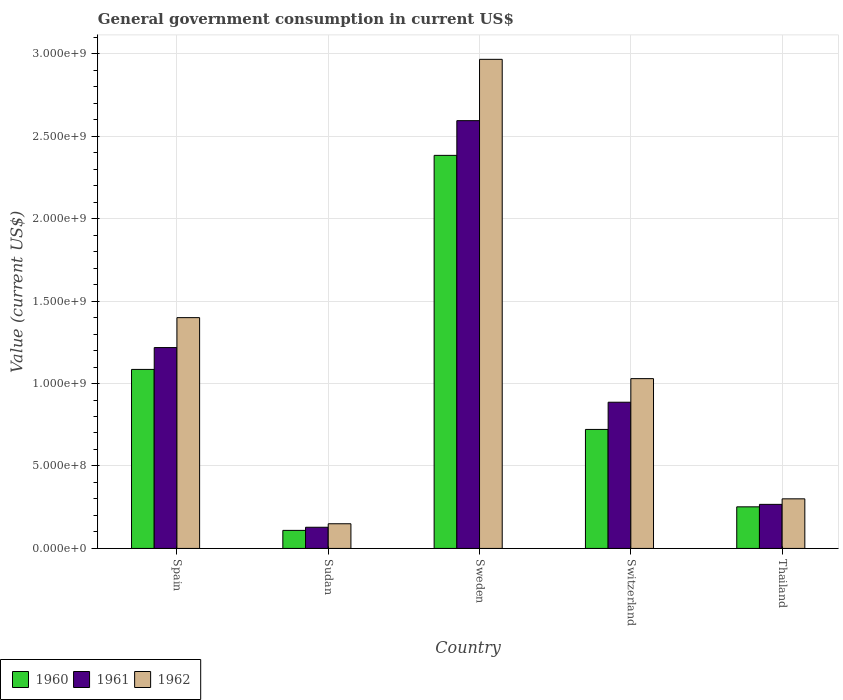How many groups of bars are there?
Your answer should be very brief. 5. Are the number of bars per tick equal to the number of legend labels?
Your response must be concise. Yes. Are the number of bars on each tick of the X-axis equal?
Offer a terse response. Yes. How many bars are there on the 1st tick from the left?
Offer a very short reply. 3. What is the label of the 3rd group of bars from the left?
Your answer should be very brief. Sweden. In how many cases, is the number of bars for a given country not equal to the number of legend labels?
Offer a terse response. 0. What is the government conusmption in 1961 in Switzerland?
Your response must be concise. 8.86e+08. Across all countries, what is the maximum government conusmption in 1960?
Provide a short and direct response. 2.38e+09. Across all countries, what is the minimum government conusmption in 1962?
Keep it short and to the point. 1.50e+08. In which country was the government conusmption in 1962 maximum?
Offer a very short reply. Sweden. In which country was the government conusmption in 1960 minimum?
Give a very brief answer. Sudan. What is the total government conusmption in 1960 in the graph?
Ensure brevity in your answer.  4.55e+09. What is the difference between the government conusmption in 1961 in Spain and that in Sudan?
Your answer should be compact. 1.09e+09. What is the difference between the government conusmption in 1961 in Switzerland and the government conusmption in 1962 in Sudan?
Your response must be concise. 7.37e+08. What is the average government conusmption in 1960 per country?
Give a very brief answer. 9.10e+08. What is the difference between the government conusmption of/in 1960 and government conusmption of/in 1961 in Sweden?
Make the answer very short. -2.10e+08. In how many countries, is the government conusmption in 1961 greater than 1600000000 US$?
Offer a terse response. 1. What is the ratio of the government conusmption in 1960 in Sweden to that in Thailand?
Keep it short and to the point. 9.45. Is the government conusmption in 1962 in Spain less than that in Sweden?
Give a very brief answer. Yes. What is the difference between the highest and the second highest government conusmption in 1960?
Offer a terse response. 1.30e+09. What is the difference between the highest and the lowest government conusmption in 1960?
Your response must be concise. 2.27e+09. In how many countries, is the government conusmption in 1962 greater than the average government conusmption in 1962 taken over all countries?
Offer a terse response. 2. Is it the case that in every country, the sum of the government conusmption in 1960 and government conusmption in 1962 is greater than the government conusmption in 1961?
Give a very brief answer. Yes. How many countries are there in the graph?
Your answer should be very brief. 5. What is the difference between two consecutive major ticks on the Y-axis?
Make the answer very short. 5.00e+08. Does the graph contain any zero values?
Ensure brevity in your answer.  No. How many legend labels are there?
Offer a very short reply. 3. How are the legend labels stacked?
Your answer should be compact. Horizontal. What is the title of the graph?
Your answer should be very brief. General government consumption in current US$. Does "2013" appear as one of the legend labels in the graph?
Ensure brevity in your answer.  No. What is the label or title of the X-axis?
Your answer should be compact. Country. What is the label or title of the Y-axis?
Your answer should be compact. Value (current US$). What is the Value (current US$) in 1960 in Spain?
Ensure brevity in your answer.  1.09e+09. What is the Value (current US$) in 1961 in Spain?
Ensure brevity in your answer.  1.22e+09. What is the Value (current US$) in 1962 in Spain?
Ensure brevity in your answer.  1.40e+09. What is the Value (current US$) in 1960 in Sudan?
Offer a terse response. 1.09e+08. What is the Value (current US$) of 1961 in Sudan?
Your answer should be very brief. 1.28e+08. What is the Value (current US$) of 1962 in Sudan?
Provide a short and direct response. 1.50e+08. What is the Value (current US$) in 1960 in Sweden?
Your response must be concise. 2.38e+09. What is the Value (current US$) in 1961 in Sweden?
Provide a short and direct response. 2.59e+09. What is the Value (current US$) of 1962 in Sweden?
Offer a very short reply. 2.97e+09. What is the Value (current US$) of 1960 in Switzerland?
Provide a succinct answer. 7.22e+08. What is the Value (current US$) in 1961 in Switzerland?
Your response must be concise. 8.86e+08. What is the Value (current US$) of 1962 in Switzerland?
Provide a short and direct response. 1.03e+09. What is the Value (current US$) in 1960 in Thailand?
Give a very brief answer. 2.52e+08. What is the Value (current US$) in 1961 in Thailand?
Ensure brevity in your answer.  2.67e+08. What is the Value (current US$) in 1962 in Thailand?
Ensure brevity in your answer.  3.01e+08. Across all countries, what is the maximum Value (current US$) in 1960?
Your answer should be very brief. 2.38e+09. Across all countries, what is the maximum Value (current US$) of 1961?
Ensure brevity in your answer.  2.59e+09. Across all countries, what is the maximum Value (current US$) of 1962?
Provide a succinct answer. 2.97e+09. Across all countries, what is the minimum Value (current US$) in 1960?
Offer a very short reply. 1.09e+08. Across all countries, what is the minimum Value (current US$) of 1961?
Offer a very short reply. 1.28e+08. Across all countries, what is the minimum Value (current US$) of 1962?
Your answer should be very brief. 1.50e+08. What is the total Value (current US$) in 1960 in the graph?
Ensure brevity in your answer.  4.55e+09. What is the total Value (current US$) in 1961 in the graph?
Keep it short and to the point. 5.09e+09. What is the total Value (current US$) of 1962 in the graph?
Make the answer very short. 5.84e+09. What is the difference between the Value (current US$) of 1960 in Spain and that in Sudan?
Keep it short and to the point. 9.76e+08. What is the difference between the Value (current US$) in 1961 in Spain and that in Sudan?
Your answer should be compact. 1.09e+09. What is the difference between the Value (current US$) of 1962 in Spain and that in Sudan?
Your answer should be compact. 1.25e+09. What is the difference between the Value (current US$) in 1960 in Spain and that in Sweden?
Ensure brevity in your answer.  -1.30e+09. What is the difference between the Value (current US$) of 1961 in Spain and that in Sweden?
Your response must be concise. -1.38e+09. What is the difference between the Value (current US$) in 1962 in Spain and that in Sweden?
Provide a short and direct response. -1.57e+09. What is the difference between the Value (current US$) of 1960 in Spain and that in Switzerland?
Provide a short and direct response. 3.64e+08. What is the difference between the Value (current US$) of 1961 in Spain and that in Switzerland?
Ensure brevity in your answer.  3.31e+08. What is the difference between the Value (current US$) of 1962 in Spain and that in Switzerland?
Your answer should be compact. 3.70e+08. What is the difference between the Value (current US$) in 1960 in Spain and that in Thailand?
Your answer should be compact. 8.33e+08. What is the difference between the Value (current US$) in 1961 in Spain and that in Thailand?
Provide a short and direct response. 9.51e+08. What is the difference between the Value (current US$) of 1962 in Spain and that in Thailand?
Provide a short and direct response. 1.10e+09. What is the difference between the Value (current US$) in 1960 in Sudan and that in Sweden?
Make the answer very short. -2.27e+09. What is the difference between the Value (current US$) of 1961 in Sudan and that in Sweden?
Give a very brief answer. -2.47e+09. What is the difference between the Value (current US$) of 1962 in Sudan and that in Sweden?
Provide a short and direct response. -2.82e+09. What is the difference between the Value (current US$) in 1960 in Sudan and that in Switzerland?
Provide a succinct answer. -6.12e+08. What is the difference between the Value (current US$) in 1961 in Sudan and that in Switzerland?
Give a very brief answer. -7.58e+08. What is the difference between the Value (current US$) in 1962 in Sudan and that in Switzerland?
Ensure brevity in your answer.  -8.80e+08. What is the difference between the Value (current US$) of 1960 in Sudan and that in Thailand?
Provide a short and direct response. -1.43e+08. What is the difference between the Value (current US$) in 1961 in Sudan and that in Thailand?
Ensure brevity in your answer.  -1.39e+08. What is the difference between the Value (current US$) of 1962 in Sudan and that in Thailand?
Your response must be concise. -1.51e+08. What is the difference between the Value (current US$) in 1960 in Sweden and that in Switzerland?
Provide a short and direct response. 1.66e+09. What is the difference between the Value (current US$) of 1961 in Sweden and that in Switzerland?
Make the answer very short. 1.71e+09. What is the difference between the Value (current US$) in 1962 in Sweden and that in Switzerland?
Make the answer very short. 1.94e+09. What is the difference between the Value (current US$) of 1960 in Sweden and that in Thailand?
Your answer should be very brief. 2.13e+09. What is the difference between the Value (current US$) in 1961 in Sweden and that in Thailand?
Make the answer very short. 2.33e+09. What is the difference between the Value (current US$) of 1962 in Sweden and that in Thailand?
Ensure brevity in your answer.  2.66e+09. What is the difference between the Value (current US$) of 1960 in Switzerland and that in Thailand?
Give a very brief answer. 4.69e+08. What is the difference between the Value (current US$) of 1961 in Switzerland and that in Thailand?
Give a very brief answer. 6.19e+08. What is the difference between the Value (current US$) in 1962 in Switzerland and that in Thailand?
Provide a succinct answer. 7.29e+08. What is the difference between the Value (current US$) of 1960 in Spain and the Value (current US$) of 1961 in Sudan?
Give a very brief answer. 9.57e+08. What is the difference between the Value (current US$) in 1960 in Spain and the Value (current US$) in 1962 in Sudan?
Offer a very short reply. 9.36e+08. What is the difference between the Value (current US$) of 1961 in Spain and the Value (current US$) of 1962 in Sudan?
Ensure brevity in your answer.  1.07e+09. What is the difference between the Value (current US$) of 1960 in Spain and the Value (current US$) of 1961 in Sweden?
Make the answer very short. -1.51e+09. What is the difference between the Value (current US$) in 1960 in Spain and the Value (current US$) in 1962 in Sweden?
Provide a succinct answer. -1.88e+09. What is the difference between the Value (current US$) of 1961 in Spain and the Value (current US$) of 1962 in Sweden?
Provide a succinct answer. -1.75e+09. What is the difference between the Value (current US$) in 1960 in Spain and the Value (current US$) in 1961 in Switzerland?
Give a very brief answer. 1.99e+08. What is the difference between the Value (current US$) of 1960 in Spain and the Value (current US$) of 1962 in Switzerland?
Your response must be concise. 5.60e+07. What is the difference between the Value (current US$) of 1961 in Spain and the Value (current US$) of 1962 in Switzerland?
Your response must be concise. 1.88e+08. What is the difference between the Value (current US$) of 1960 in Spain and the Value (current US$) of 1961 in Thailand?
Ensure brevity in your answer.  8.18e+08. What is the difference between the Value (current US$) in 1960 in Spain and the Value (current US$) in 1962 in Thailand?
Provide a short and direct response. 7.85e+08. What is the difference between the Value (current US$) of 1961 in Spain and the Value (current US$) of 1962 in Thailand?
Provide a succinct answer. 9.17e+08. What is the difference between the Value (current US$) of 1960 in Sudan and the Value (current US$) of 1961 in Sweden?
Keep it short and to the point. -2.48e+09. What is the difference between the Value (current US$) of 1960 in Sudan and the Value (current US$) of 1962 in Sweden?
Your answer should be very brief. -2.86e+09. What is the difference between the Value (current US$) in 1961 in Sudan and the Value (current US$) in 1962 in Sweden?
Give a very brief answer. -2.84e+09. What is the difference between the Value (current US$) of 1960 in Sudan and the Value (current US$) of 1961 in Switzerland?
Your answer should be very brief. -7.77e+08. What is the difference between the Value (current US$) of 1960 in Sudan and the Value (current US$) of 1962 in Switzerland?
Your response must be concise. -9.20e+08. What is the difference between the Value (current US$) of 1961 in Sudan and the Value (current US$) of 1962 in Switzerland?
Provide a short and direct response. -9.01e+08. What is the difference between the Value (current US$) in 1960 in Sudan and the Value (current US$) in 1961 in Thailand?
Your answer should be very brief. -1.58e+08. What is the difference between the Value (current US$) in 1960 in Sudan and the Value (current US$) in 1962 in Thailand?
Your answer should be very brief. -1.91e+08. What is the difference between the Value (current US$) in 1961 in Sudan and the Value (current US$) in 1962 in Thailand?
Your answer should be very brief. -1.72e+08. What is the difference between the Value (current US$) of 1960 in Sweden and the Value (current US$) of 1961 in Switzerland?
Ensure brevity in your answer.  1.50e+09. What is the difference between the Value (current US$) in 1960 in Sweden and the Value (current US$) in 1962 in Switzerland?
Provide a succinct answer. 1.35e+09. What is the difference between the Value (current US$) in 1961 in Sweden and the Value (current US$) in 1962 in Switzerland?
Offer a terse response. 1.56e+09. What is the difference between the Value (current US$) in 1960 in Sweden and the Value (current US$) in 1961 in Thailand?
Your answer should be compact. 2.12e+09. What is the difference between the Value (current US$) of 1960 in Sweden and the Value (current US$) of 1962 in Thailand?
Keep it short and to the point. 2.08e+09. What is the difference between the Value (current US$) in 1961 in Sweden and the Value (current US$) in 1962 in Thailand?
Provide a short and direct response. 2.29e+09. What is the difference between the Value (current US$) of 1960 in Switzerland and the Value (current US$) of 1961 in Thailand?
Your answer should be very brief. 4.54e+08. What is the difference between the Value (current US$) in 1960 in Switzerland and the Value (current US$) in 1962 in Thailand?
Ensure brevity in your answer.  4.21e+08. What is the difference between the Value (current US$) in 1961 in Switzerland and the Value (current US$) in 1962 in Thailand?
Your response must be concise. 5.86e+08. What is the average Value (current US$) in 1960 per country?
Make the answer very short. 9.10e+08. What is the average Value (current US$) of 1961 per country?
Your answer should be compact. 1.02e+09. What is the average Value (current US$) of 1962 per country?
Provide a succinct answer. 1.17e+09. What is the difference between the Value (current US$) of 1960 and Value (current US$) of 1961 in Spain?
Ensure brevity in your answer.  -1.32e+08. What is the difference between the Value (current US$) in 1960 and Value (current US$) in 1962 in Spain?
Your answer should be very brief. -3.14e+08. What is the difference between the Value (current US$) of 1961 and Value (current US$) of 1962 in Spain?
Keep it short and to the point. -1.82e+08. What is the difference between the Value (current US$) in 1960 and Value (current US$) in 1961 in Sudan?
Give a very brief answer. -1.90e+07. What is the difference between the Value (current US$) of 1960 and Value (current US$) of 1962 in Sudan?
Provide a succinct answer. -4.02e+07. What is the difference between the Value (current US$) of 1961 and Value (current US$) of 1962 in Sudan?
Offer a terse response. -2.13e+07. What is the difference between the Value (current US$) of 1960 and Value (current US$) of 1961 in Sweden?
Ensure brevity in your answer.  -2.10e+08. What is the difference between the Value (current US$) in 1960 and Value (current US$) in 1962 in Sweden?
Offer a very short reply. -5.82e+08. What is the difference between the Value (current US$) of 1961 and Value (current US$) of 1962 in Sweden?
Your answer should be compact. -3.72e+08. What is the difference between the Value (current US$) of 1960 and Value (current US$) of 1961 in Switzerland?
Give a very brief answer. -1.65e+08. What is the difference between the Value (current US$) of 1960 and Value (current US$) of 1962 in Switzerland?
Your answer should be very brief. -3.08e+08. What is the difference between the Value (current US$) in 1961 and Value (current US$) in 1962 in Switzerland?
Your answer should be compact. -1.43e+08. What is the difference between the Value (current US$) of 1960 and Value (current US$) of 1961 in Thailand?
Make the answer very short. -1.50e+07. What is the difference between the Value (current US$) of 1960 and Value (current US$) of 1962 in Thailand?
Your answer should be compact. -4.86e+07. What is the difference between the Value (current US$) of 1961 and Value (current US$) of 1962 in Thailand?
Your answer should be very brief. -3.36e+07. What is the ratio of the Value (current US$) of 1960 in Spain to that in Sudan?
Offer a terse response. 9.92. What is the ratio of the Value (current US$) of 1961 in Spain to that in Sudan?
Give a very brief answer. 9.49. What is the ratio of the Value (current US$) of 1962 in Spain to that in Sudan?
Your answer should be very brief. 9.35. What is the ratio of the Value (current US$) in 1960 in Spain to that in Sweden?
Keep it short and to the point. 0.46. What is the ratio of the Value (current US$) of 1961 in Spain to that in Sweden?
Provide a short and direct response. 0.47. What is the ratio of the Value (current US$) of 1962 in Spain to that in Sweden?
Provide a short and direct response. 0.47. What is the ratio of the Value (current US$) of 1960 in Spain to that in Switzerland?
Your answer should be very brief. 1.5. What is the ratio of the Value (current US$) of 1961 in Spain to that in Switzerland?
Make the answer very short. 1.37. What is the ratio of the Value (current US$) of 1962 in Spain to that in Switzerland?
Keep it short and to the point. 1.36. What is the ratio of the Value (current US$) in 1960 in Spain to that in Thailand?
Provide a short and direct response. 4.3. What is the ratio of the Value (current US$) in 1961 in Spain to that in Thailand?
Offer a very short reply. 4.56. What is the ratio of the Value (current US$) of 1962 in Spain to that in Thailand?
Your answer should be very brief. 4.65. What is the ratio of the Value (current US$) in 1960 in Sudan to that in Sweden?
Offer a very short reply. 0.05. What is the ratio of the Value (current US$) of 1961 in Sudan to that in Sweden?
Offer a terse response. 0.05. What is the ratio of the Value (current US$) in 1962 in Sudan to that in Sweden?
Offer a terse response. 0.05. What is the ratio of the Value (current US$) of 1960 in Sudan to that in Switzerland?
Offer a terse response. 0.15. What is the ratio of the Value (current US$) in 1961 in Sudan to that in Switzerland?
Provide a short and direct response. 0.14. What is the ratio of the Value (current US$) of 1962 in Sudan to that in Switzerland?
Offer a very short reply. 0.15. What is the ratio of the Value (current US$) in 1960 in Sudan to that in Thailand?
Keep it short and to the point. 0.43. What is the ratio of the Value (current US$) of 1961 in Sudan to that in Thailand?
Your answer should be compact. 0.48. What is the ratio of the Value (current US$) in 1962 in Sudan to that in Thailand?
Give a very brief answer. 0.5. What is the ratio of the Value (current US$) of 1960 in Sweden to that in Switzerland?
Your answer should be very brief. 3.3. What is the ratio of the Value (current US$) in 1961 in Sweden to that in Switzerland?
Give a very brief answer. 2.93. What is the ratio of the Value (current US$) of 1962 in Sweden to that in Switzerland?
Make the answer very short. 2.88. What is the ratio of the Value (current US$) of 1960 in Sweden to that in Thailand?
Keep it short and to the point. 9.45. What is the ratio of the Value (current US$) in 1961 in Sweden to that in Thailand?
Give a very brief answer. 9.71. What is the ratio of the Value (current US$) of 1962 in Sweden to that in Thailand?
Give a very brief answer. 9.86. What is the ratio of the Value (current US$) in 1960 in Switzerland to that in Thailand?
Provide a succinct answer. 2.86. What is the ratio of the Value (current US$) of 1961 in Switzerland to that in Thailand?
Provide a succinct answer. 3.32. What is the ratio of the Value (current US$) of 1962 in Switzerland to that in Thailand?
Your answer should be very brief. 3.42. What is the difference between the highest and the second highest Value (current US$) of 1960?
Keep it short and to the point. 1.30e+09. What is the difference between the highest and the second highest Value (current US$) in 1961?
Offer a terse response. 1.38e+09. What is the difference between the highest and the second highest Value (current US$) of 1962?
Ensure brevity in your answer.  1.57e+09. What is the difference between the highest and the lowest Value (current US$) of 1960?
Make the answer very short. 2.27e+09. What is the difference between the highest and the lowest Value (current US$) of 1961?
Your answer should be very brief. 2.47e+09. What is the difference between the highest and the lowest Value (current US$) of 1962?
Keep it short and to the point. 2.82e+09. 